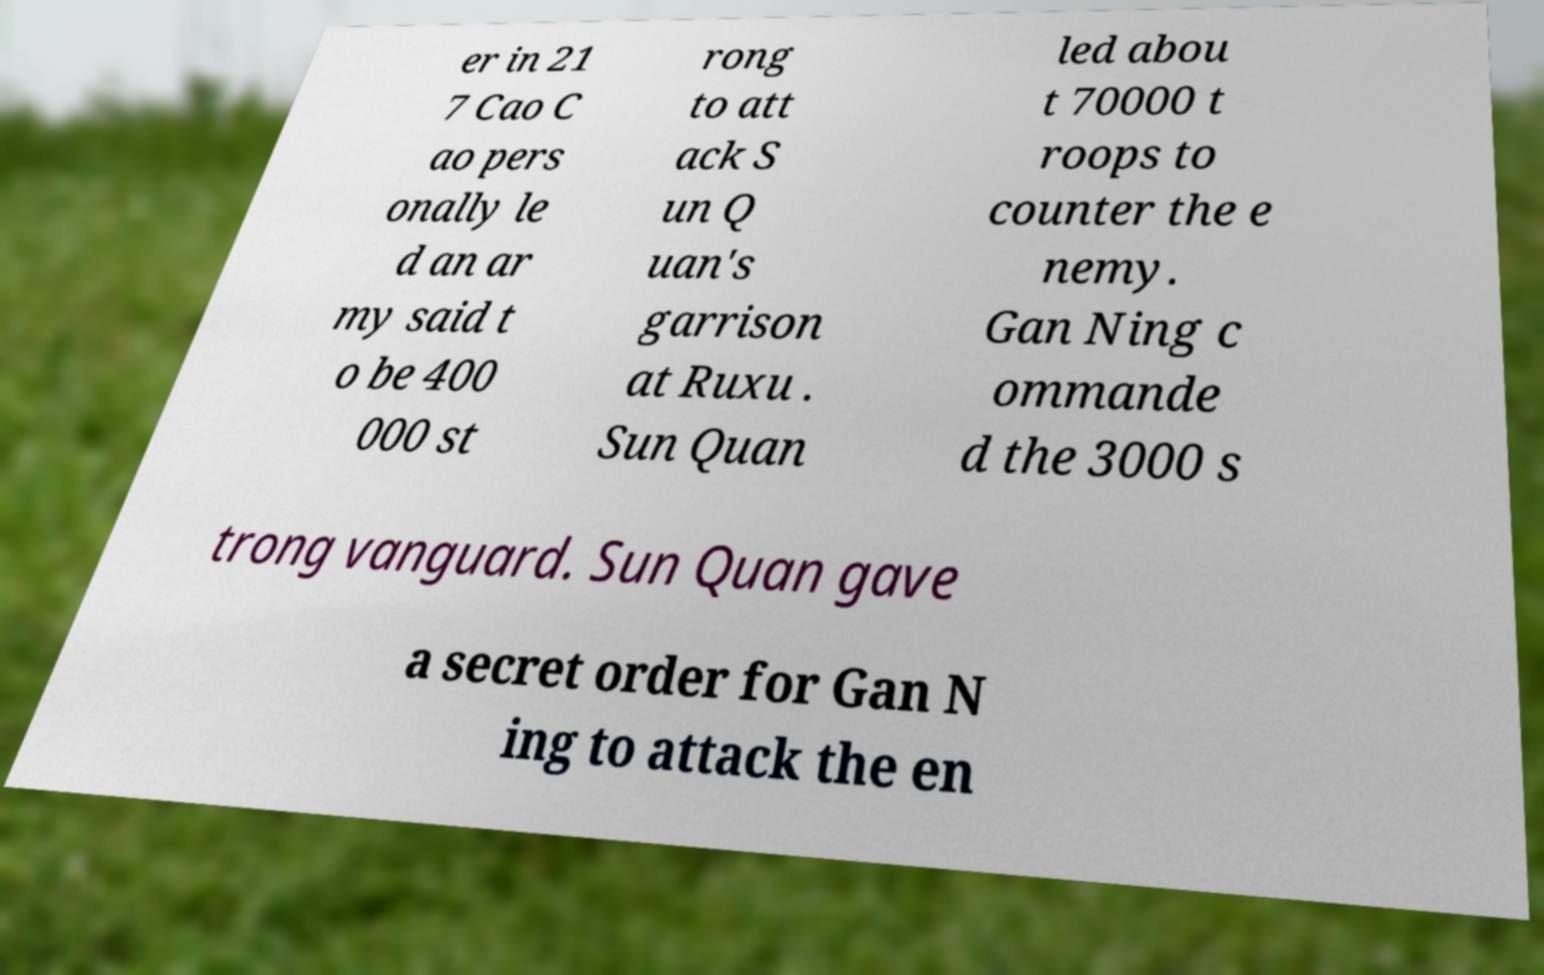Could you assist in decoding the text presented in this image and type it out clearly? er in 21 7 Cao C ao pers onally le d an ar my said t o be 400 000 st rong to att ack S un Q uan's garrison at Ruxu . Sun Quan led abou t 70000 t roops to counter the e nemy. Gan Ning c ommande d the 3000 s trong vanguard. Sun Quan gave a secret order for Gan N ing to attack the en 